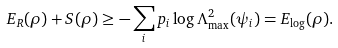<formula> <loc_0><loc_0><loc_500><loc_500>E _ { R } ( { \rho } ) + S ( { \rho } ) \geq - \sum _ { i } p _ { i } \log \Lambda _ { \max } ^ { 2 } ( \psi _ { i } ) = E _ { \log } ( \rho ) .</formula> 